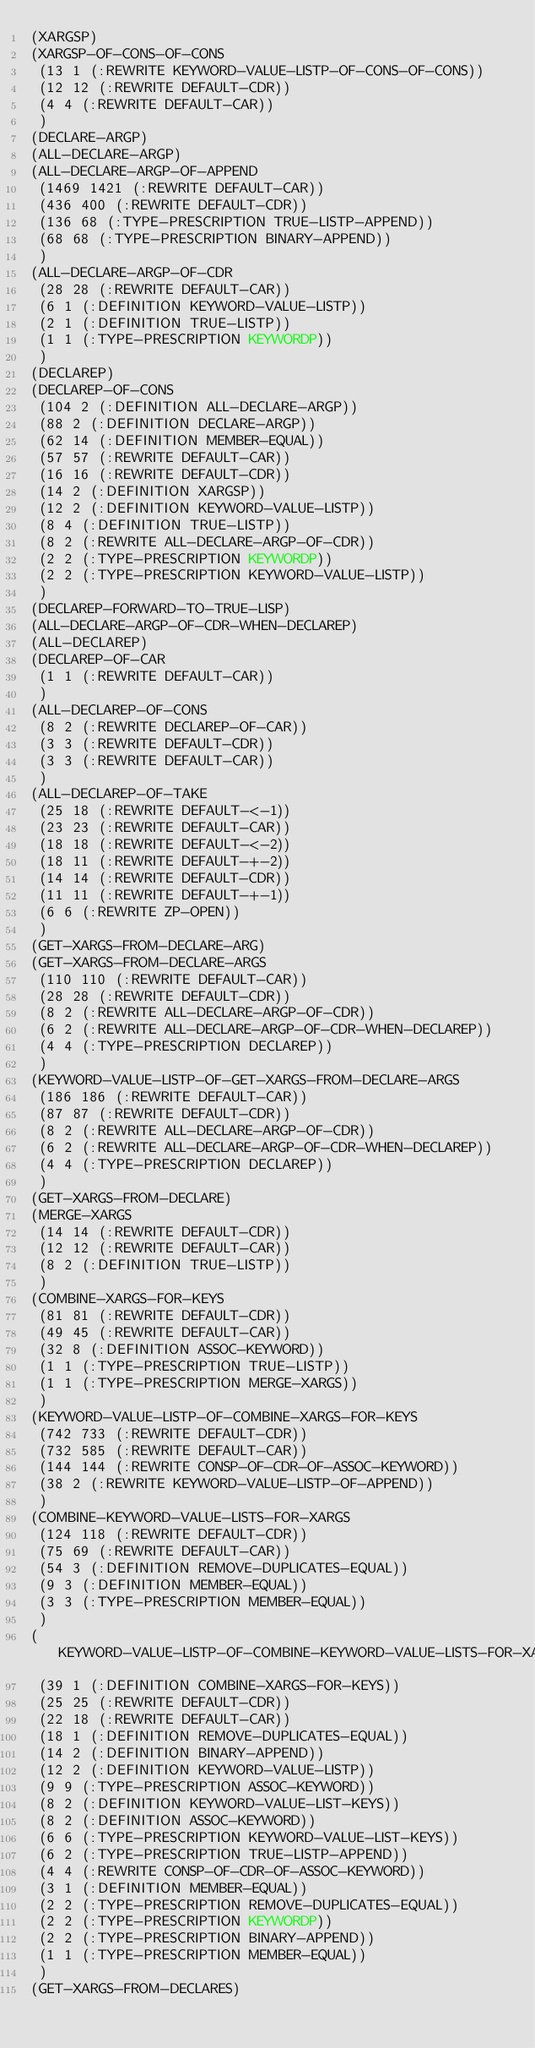Convert code to text. <code><loc_0><loc_0><loc_500><loc_500><_Lisp_>(XARGSP)
(XARGSP-OF-CONS-OF-CONS
 (13 1 (:REWRITE KEYWORD-VALUE-LISTP-OF-CONS-OF-CONS))
 (12 12 (:REWRITE DEFAULT-CDR))
 (4 4 (:REWRITE DEFAULT-CAR))
 )
(DECLARE-ARGP)
(ALL-DECLARE-ARGP)
(ALL-DECLARE-ARGP-OF-APPEND
 (1469 1421 (:REWRITE DEFAULT-CAR))
 (436 400 (:REWRITE DEFAULT-CDR))
 (136 68 (:TYPE-PRESCRIPTION TRUE-LISTP-APPEND))
 (68 68 (:TYPE-PRESCRIPTION BINARY-APPEND))
 )
(ALL-DECLARE-ARGP-OF-CDR
 (28 28 (:REWRITE DEFAULT-CAR))
 (6 1 (:DEFINITION KEYWORD-VALUE-LISTP))
 (2 1 (:DEFINITION TRUE-LISTP))
 (1 1 (:TYPE-PRESCRIPTION KEYWORDP))
 )
(DECLAREP)
(DECLAREP-OF-CONS
 (104 2 (:DEFINITION ALL-DECLARE-ARGP))
 (88 2 (:DEFINITION DECLARE-ARGP))
 (62 14 (:DEFINITION MEMBER-EQUAL))
 (57 57 (:REWRITE DEFAULT-CAR))
 (16 16 (:REWRITE DEFAULT-CDR))
 (14 2 (:DEFINITION XARGSP))
 (12 2 (:DEFINITION KEYWORD-VALUE-LISTP))
 (8 4 (:DEFINITION TRUE-LISTP))
 (8 2 (:REWRITE ALL-DECLARE-ARGP-OF-CDR))
 (2 2 (:TYPE-PRESCRIPTION KEYWORDP))
 (2 2 (:TYPE-PRESCRIPTION KEYWORD-VALUE-LISTP))
 )
(DECLAREP-FORWARD-TO-TRUE-LISP)
(ALL-DECLARE-ARGP-OF-CDR-WHEN-DECLAREP)
(ALL-DECLAREP)
(DECLAREP-OF-CAR
 (1 1 (:REWRITE DEFAULT-CAR))
 )
(ALL-DECLAREP-OF-CONS
 (8 2 (:REWRITE DECLAREP-OF-CAR))
 (3 3 (:REWRITE DEFAULT-CDR))
 (3 3 (:REWRITE DEFAULT-CAR))
 )
(ALL-DECLAREP-OF-TAKE
 (25 18 (:REWRITE DEFAULT-<-1))
 (23 23 (:REWRITE DEFAULT-CAR))
 (18 18 (:REWRITE DEFAULT-<-2))
 (18 11 (:REWRITE DEFAULT-+-2))
 (14 14 (:REWRITE DEFAULT-CDR))
 (11 11 (:REWRITE DEFAULT-+-1))
 (6 6 (:REWRITE ZP-OPEN))
 )
(GET-XARGS-FROM-DECLARE-ARG)
(GET-XARGS-FROM-DECLARE-ARGS
 (110 110 (:REWRITE DEFAULT-CAR))
 (28 28 (:REWRITE DEFAULT-CDR))
 (8 2 (:REWRITE ALL-DECLARE-ARGP-OF-CDR))
 (6 2 (:REWRITE ALL-DECLARE-ARGP-OF-CDR-WHEN-DECLAREP))
 (4 4 (:TYPE-PRESCRIPTION DECLAREP))
 )
(KEYWORD-VALUE-LISTP-OF-GET-XARGS-FROM-DECLARE-ARGS
 (186 186 (:REWRITE DEFAULT-CAR))
 (87 87 (:REWRITE DEFAULT-CDR))
 (8 2 (:REWRITE ALL-DECLARE-ARGP-OF-CDR))
 (6 2 (:REWRITE ALL-DECLARE-ARGP-OF-CDR-WHEN-DECLAREP))
 (4 4 (:TYPE-PRESCRIPTION DECLAREP))
 )
(GET-XARGS-FROM-DECLARE)
(MERGE-XARGS
 (14 14 (:REWRITE DEFAULT-CDR))
 (12 12 (:REWRITE DEFAULT-CAR))
 (8 2 (:DEFINITION TRUE-LISTP))
 )
(COMBINE-XARGS-FOR-KEYS
 (81 81 (:REWRITE DEFAULT-CDR))
 (49 45 (:REWRITE DEFAULT-CAR))
 (32 8 (:DEFINITION ASSOC-KEYWORD))
 (1 1 (:TYPE-PRESCRIPTION TRUE-LISTP))
 (1 1 (:TYPE-PRESCRIPTION MERGE-XARGS))
 )
(KEYWORD-VALUE-LISTP-OF-COMBINE-XARGS-FOR-KEYS
 (742 733 (:REWRITE DEFAULT-CDR))
 (732 585 (:REWRITE DEFAULT-CAR))
 (144 144 (:REWRITE CONSP-OF-CDR-OF-ASSOC-KEYWORD))
 (38 2 (:REWRITE KEYWORD-VALUE-LISTP-OF-APPEND))
 )
(COMBINE-KEYWORD-VALUE-LISTS-FOR-XARGS
 (124 118 (:REWRITE DEFAULT-CDR))
 (75 69 (:REWRITE DEFAULT-CAR))
 (54 3 (:DEFINITION REMOVE-DUPLICATES-EQUAL))
 (9 3 (:DEFINITION MEMBER-EQUAL))
 (3 3 (:TYPE-PRESCRIPTION MEMBER-EQUAL))
 )
(KEYWORD-VALUE-LISTP-OF-COMBINE-KEYWORD-VALUE-LISTS-FOR-XARGS
 (39 1 (:DEFINITION COMBINE-XARGS-FOR-KEYS))
 (25 25 (:REWRITE DEFAULT-CDR))
 (22 18 (:REWRITE DEFAULT-CAR))
 (18 1 (:DEFINITION REMOVE-DUPLICATES-EQUAL))
 (14 2 (:DEFINITION BINARY-APPEND))
 (12 2 (:DEFINITION KEYWORD-VALUE-LISTP))
 (9 9 (:TYPE-PRESCRIPTION ASSOC-KEYWORD))
 (8 2 (:DEFINITION KEYWORD-VALUE-LIST-KEYS))
 (8 2 (:DEFINITION ASSOC-KEYWORD))
 (6 6 (:TYPE-PRESCRIPTION KEYWORD-VALUE-LIST-KEYS))
 (6 2 (:TYPE-PRESCRIPTION TRUE-LISTP-APPEND))
 (4 4 (:REWRITE CONSP-OF-CDR-OF-ASSOC-KEYWORD))
 (3 1 (:DEFINITION MEMBER-EQUAL))
 (2 2 (:TYPE-PRESCRIPTION REMOVE-DUPLICATES-EQUAL))
 (2 2 (:TYPE-PRESCRIPTION KEYWORDP))
 (2 2 (:TYPE-PRESCRIPTION BINARY-APPEND))
 (1 1 (:TYPE-PRESCRIPTION MEMBER-EQUAL))
 )
(GET-XARGS-FROM-DECLARES)</code> 